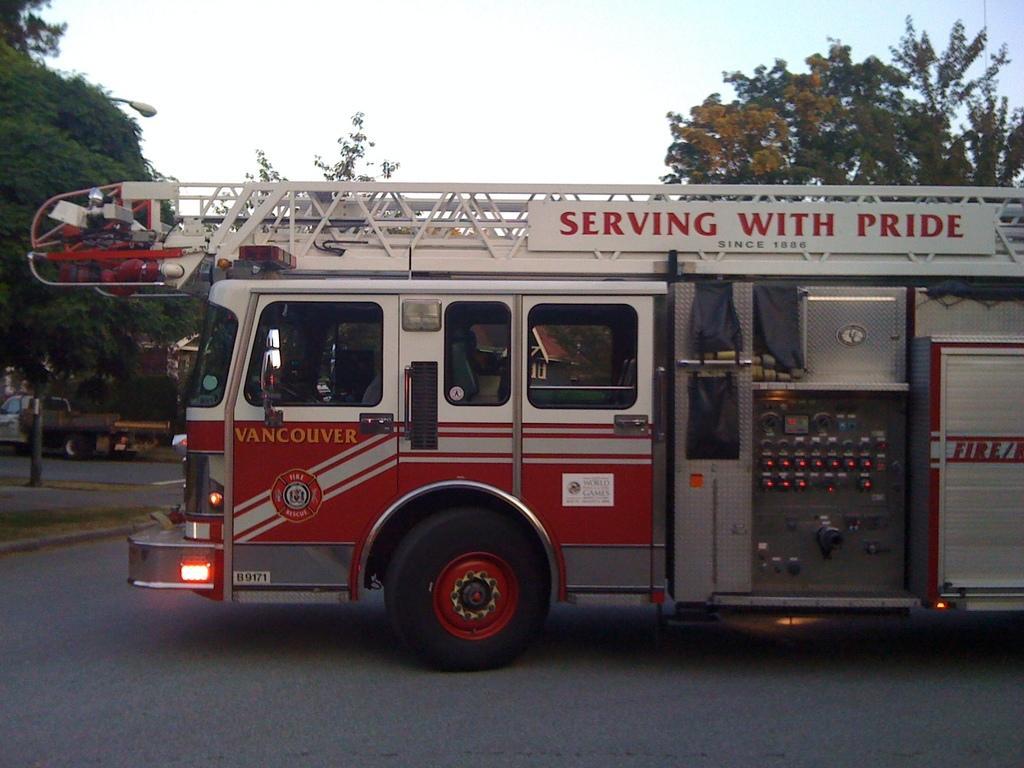Describe this image in one or two sentences. In this image in the center there is a vehicle, and at the bottom there is a road. And on the left side of the image there is another vehicle and some buildings, trees, and there is a street light. At the top there is sky, and in the background there are trees. 